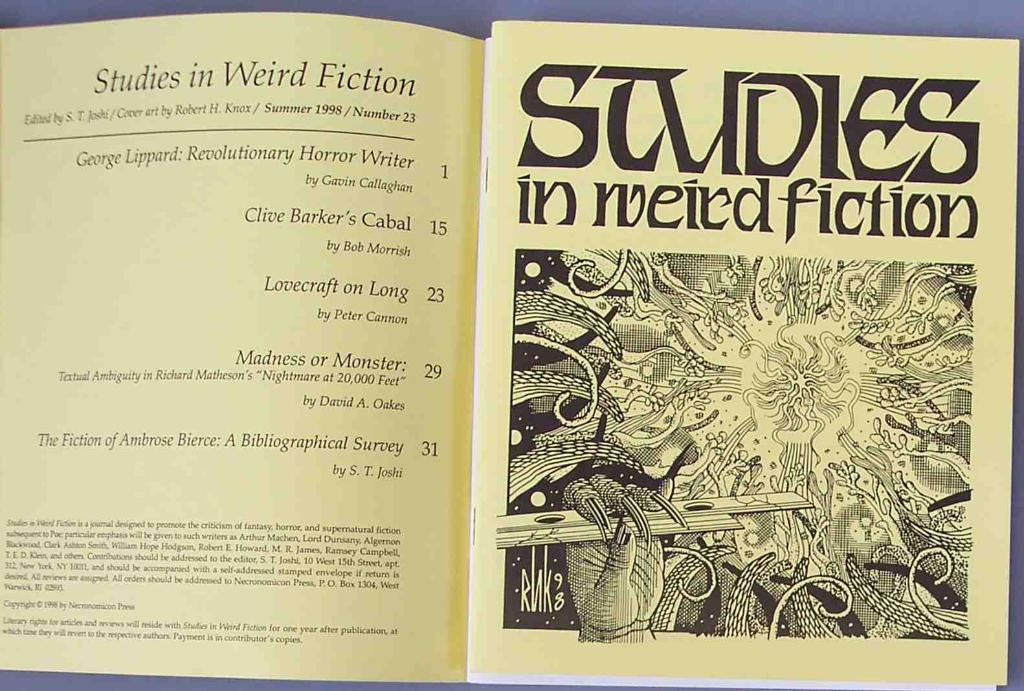What is on page 15 of the book?
Give a very brief answer. Clive barker's cabal. What kind of fiction is this article about?
Provide a succinct answer. Weird. 